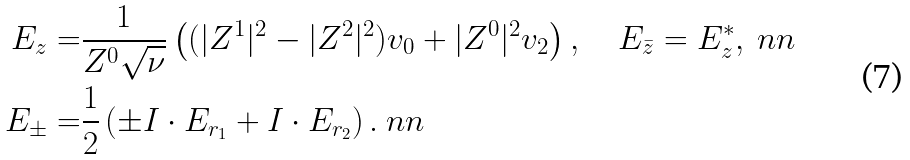<formula> <loc_0><loc_0><loc_500><loc_500>E _ { z } = & \frac { 1 } { Z ^ { 0 } \sqrt { \nu } } \left ( ( | Z ^ { 1 } | ^ { 2 } - | Z ^ { 2 } | ^ { 2 } ) v _ { 0 } + | { Z } ^ { 0 } | ^ { 2 } v _ { 2 } \right ) , \quad E _ { \bar { z } } = E _ { z } ^ { \ast } , \ n n \\ E _ { \pm } = & \frac { 1 } { 2 } \left ( \pm I \cdot E _ { r _ { 1 } } + I \cdot E _ { r _ { 2 } } \right ) . \ n n</formula> 